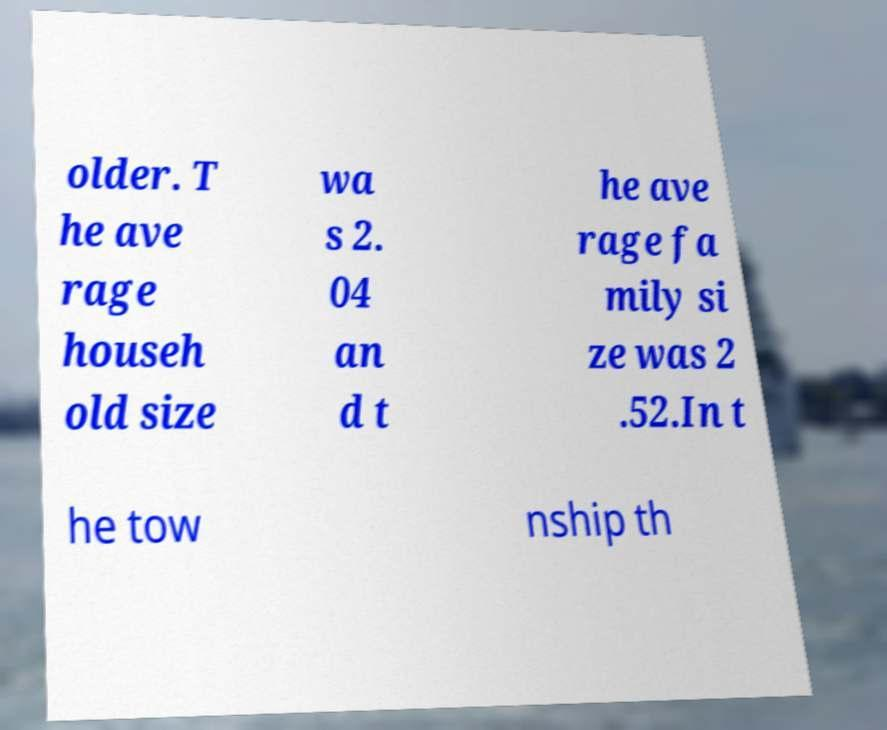Can you read and provide the text displayed in the image?This photo seems to have some interesting text. Can you extract and type it out for me? older. T he ave rage househ old size wa s 2. 04 an d t he ave rage fa mily si ze was 2 .52.In t he tow nship th 